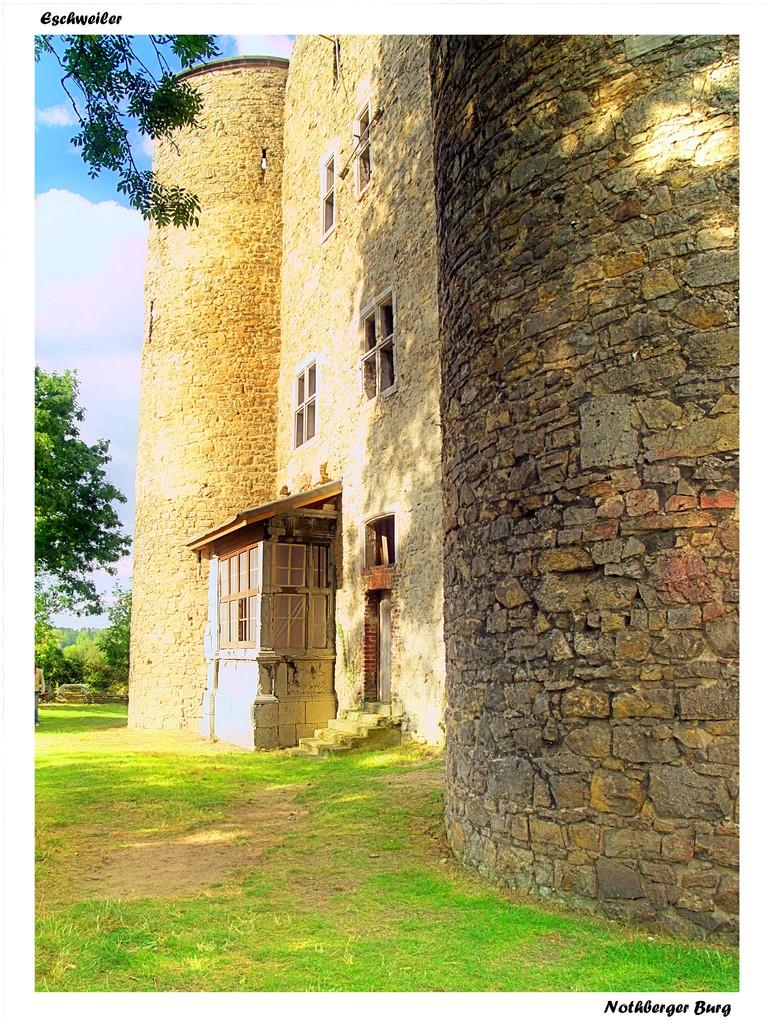What structure is located on the right side of the image? There is a building in the right side of the image. What can be seen in the background of the image? There are trees in the background of the image. What is the condition of the sky in the image? The sky is cloudy in the image. What features can be seen on the wall of the building? There are windows and a door on the wall of the building. What type of sticks are being used for arithmetic in the image? There are no sticks or arithmetic-related activities present in the image. 